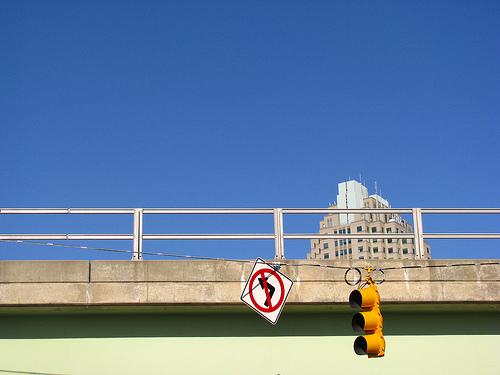Explain the purpose and design of the sign seen in the image. The sign is a red, white, and black no left turn traffic sign with a struckout red circle and black arrow. Identify the color and material of the railing on the bridge. The railing on the bridge is made of metal and is a part of a light brown bridge structure. Describe the color and structure of the bridge visible in the image. The bridge is light brown with a concrete portion and has a metal railing and vertical posts. Briefly describe the appearance of the sky in the image. The sky is a deep blue, cloudless, bright, and clear. Mention some key elements of the image's sentiment or mood. The deep blue sky and bright yellow traffic light evoke a calm urban atmosphere. What kind of sign is hanging on the bridge?  A red and white do not turn sign is hanging on the bridge. What is the overall color of the bridge? Light brown Notice the elderly man walking on the bridge with a blue umbrella, trying to avoid the sunlight. If you look closely, he is wearing a striped shirt and grey pants. Create a multimodal representation of the scene, combining the visual elements and descriptions provided. Clear blue sky, light brown city bridge with metal railing, brown and green building with lots of windows, red and white no left turn sign with black arrow hanging on bridge, yellow traffic light hanging in the air. What is the overall color and style of the bridge in front of the building? Light brown, concrete city bridge Describe the portions of the bridge in the image. Concrete city bridge, light brown, metal railing, vertical posts Please spot the graffiti on the side of the building that spells "LOVE" in large, colorful letters. What emotions does this urban art evoke in you? What is the overall color and style of the building behind the bridge? Green and brown, large commercial building Detail the main components of the traffic light. Top, middle, and bottom segment, all yellow, hanging in the air Please describe the color and state of the sky. Bright blue and clear What is the color of the arrow on the sign? Black What does the traffic sign with the red circle and black arrow indicate? No left turn Can you see the purple bird resting on the edge of the bridge, near the corner? This bird is rather small and might be hard to miss on this image. Observe the thin white dog running across the bridge, playing gleefully. Can you sense the joy and energy of the dog in its movement? Find the little red car parked next to the building with lots of windows. Its distinctive color makes it stand out. Do you think the car belongs to someone who works in that building? Is the sky clear or does it have clouds? Clear What color is the sign hanging on the bridge? Red and white Describe the appearance of the windows on the building. Cluster of windows, lots of windows Can you locate the rainbow peeking out from behind the building? It seems like a perfect day for a rainbow! Isn't this a lovely indication of the weather? What are the colors of the building in the image? Brown and green Which of the following best describes the traffic light in the image? a) Green b) Yellow c) Red b) Yellow How would you describe the railing of the bridge? Metal, with a vertical post and uppermost horizontal bar Please describe the condition of the sky in the image. Deep blue, clear, and cloudless What type of sign is hanging on the bridge? No left turn sign Identify the type, color, and position of the sign on the bridge along with a black arrow. No left turn sign, red, white, and black, hanging on the bridge 